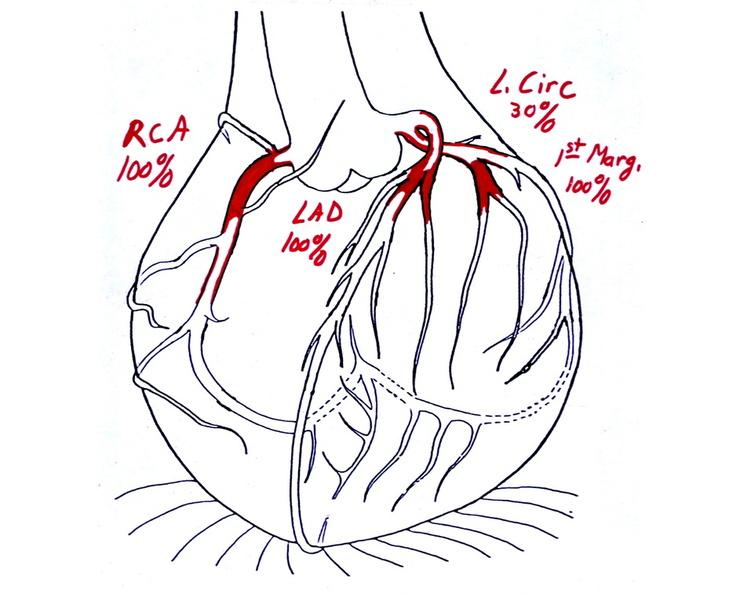where is this area in the body?
Answer the question using a single word or phrase. Heart 